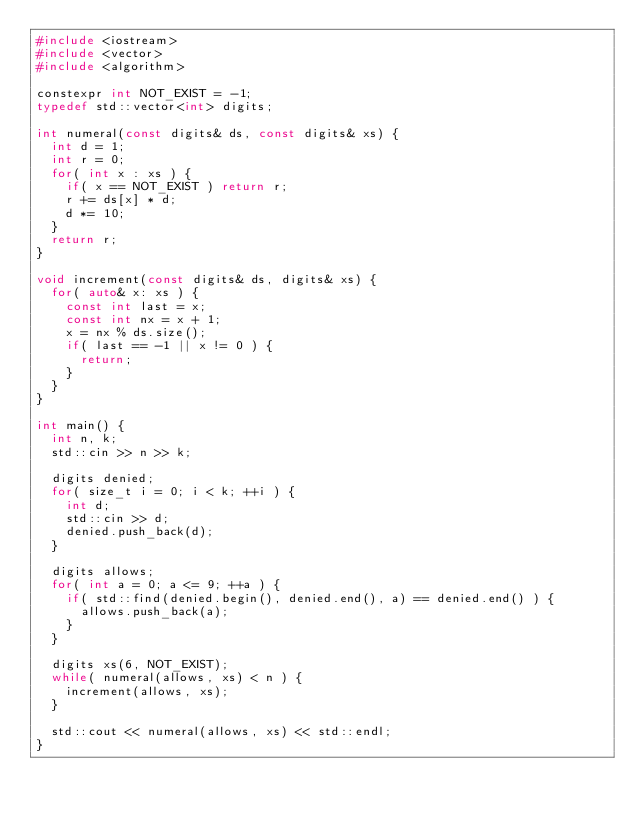Convert code to text. <code><loc_0><loc_0><loc_500><loc_500><_C++_>#include <iostream>
#include <vector>
#include <algorithm>

constexpr int NOT_EXIST = -1;
typedef std::vector<int> digits;

int numeral(const digits& ds, const digits& xs) {
  int d = 1;
  int r = 0;
  for( int x : xs ) {
    if( x == NOT_EXIST ) return r;
    r += ds[x] * d;
    d *= 10;
  }
  return r;
}

void increment(const digits& ds, digits& xs) {
  for( auto& x: xs ) {
    const int last = x;
    const int nx = x + 1;
    x = nx % ds.size();
    if( last == -1 || x != 0 ) {
      return;
    }
  }
}

int main() {
  int n, k;
  std::cin >> n >> k;

  digits denied;
  for( size_t i = 0; i < k; ++i ) {
    int d;
    std::cin >> d;
    denied.push_back(d);
  }

  digits allows;
  for( int a = 0; a <= 9; ++a ) {
    if( std::find(denied.begin(), denied.end(), a) == denied.end() ) {
      allows.push_back(a);
    }
  }

  digits xs(6, NOT_EXIST);
  while( numeral(allows, xs) < n ) {
    increment(allows, xs);
  }

  std::cout << numeral(allows, xs) << std::endl;
}</code> 